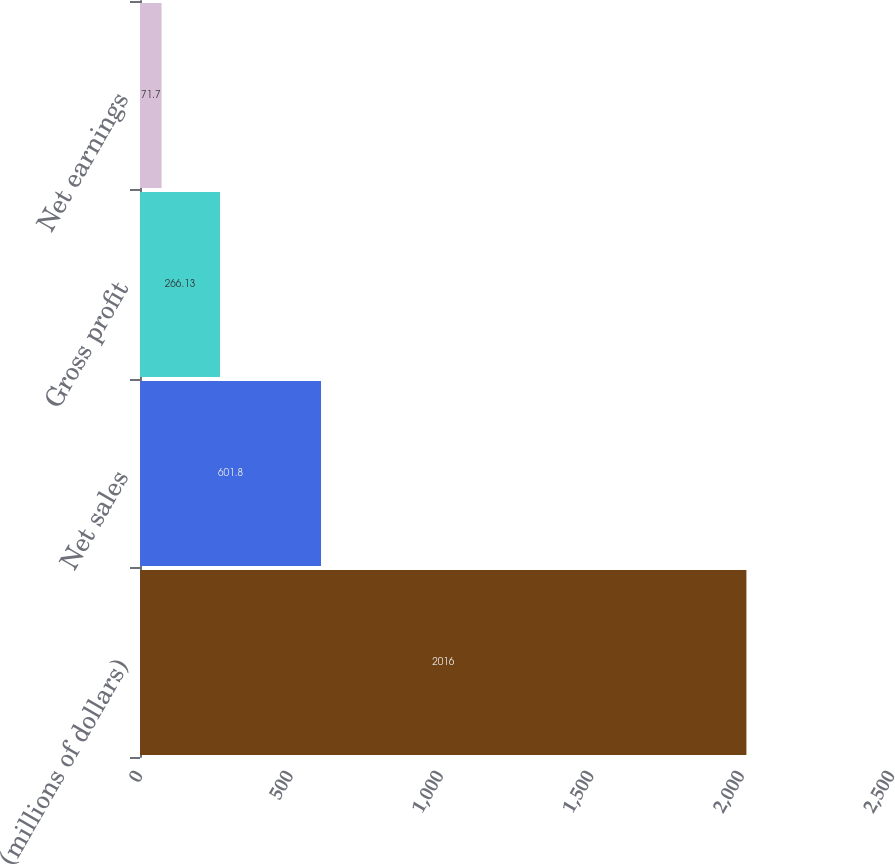Convert chart to OTSL. <chart><loc_0><loc_0><loc_500><loc_500><bar_chart><fcel>(millions of dollars)<fcel>Net sales<fcel>Gross profit<fcel>Net earnings<nl><fcel>2016<fcel>601.8<fcel>266.13<fcel>71.7<nl></chart> 